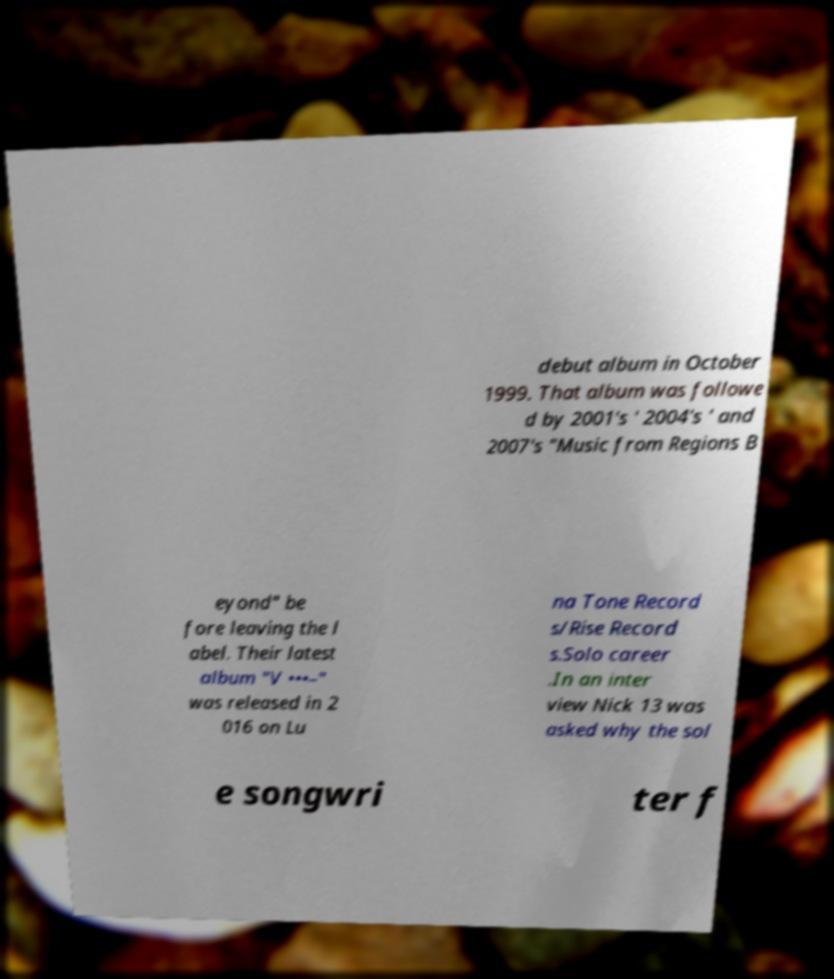Please read and relay the text visible in this image. What does it say? debut album in October 1999. That album was followe d by 2001's ' 2004's ' and 2007's "Music from Regions B eyond" be fore leaving the l abel. Their latest album "V •••–" was released in 2 016 on Lu na Tone Record s/Rise Record s.Solo career .In an inter view Nick 13 was asked why the sol e songwri ter f 